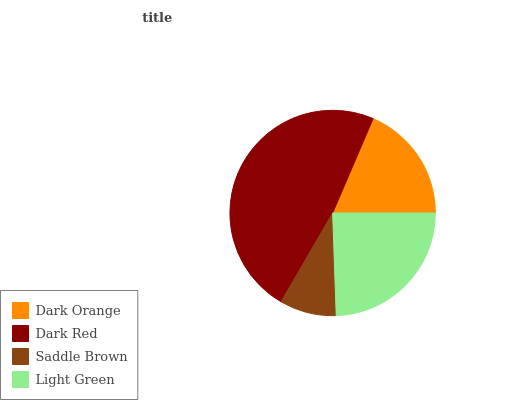Is Saddle Brown the minimum?
Answer yes or no. Yes. Is Dark Red the maximum?
Answer yes or no. Yes. Is Dark Red the minimum?
Answer yes or no. No. Is Saddle Brown the maximum?
Answer yes or no. No. Is Dark Red greater than Saddle Brown?
Answer yes or no. Yes. Is Saddle Brown less than Dark Red?
Answer yes or no. Yes. Is Saddle Brown greater than Dark Red?
Answer yes or no. No. Is Dark Red less than Saddle Brown?
Answer yes or no. No. Is Light Green the high median?
Answer yes or no. Yes. Is Dark Orange the low median?
Answer yes or no. Yes. Is Dark Orange the high median?
Answer yes or no. No. Is Dark Red the low median?
Answer yes or no. No. 